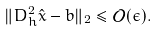Convert formula to latex. <formula><loc_0><loc_0><loc_500><loc_500>\| D _ { h } ^ { 2 } \hat { x } - b \| _ { 2 } \leq { \mathcal { O } } ( \epsilon ) .</formula> 